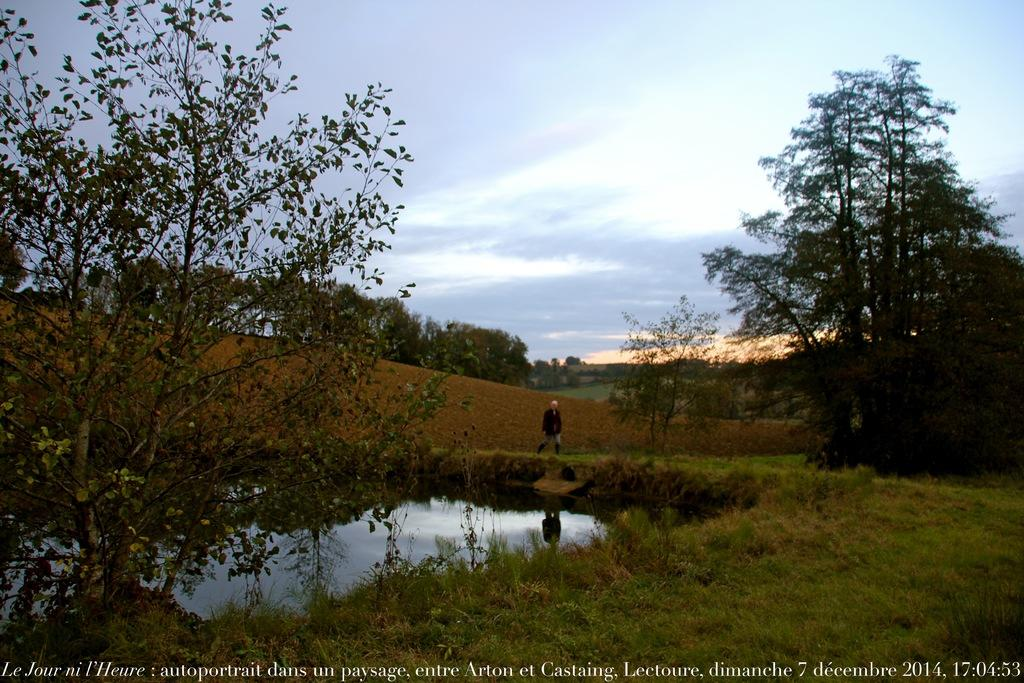What is the main subject of the image? There is a person standing in the image. What can be seen in the background of the image? The sky is visible in the background of the image. What type of natural environment is present in the image? There are trees and water visible in the image. Is there any indication of the image's origin or ownership? Yes, there is a watermark on the image. How many eyes can be seen on the deer in the image? There is no deer present in the image; it features a person standing in a natural environment with trees and water. 